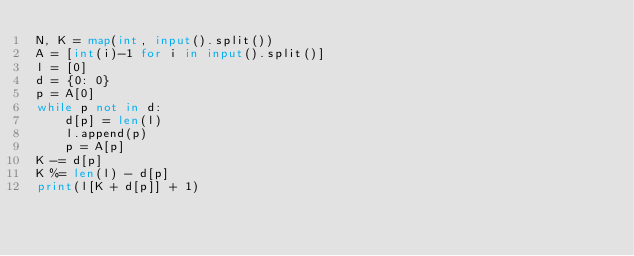Convert code to text. <code><loc_0><loc_0><loc_500><loc_500><_Python_>N, K = map(int, input().split())
A = [int(i)-1 for i in input().split()]
l = [0]
d = {0: 0}
p = A[0]
while p not in d:
    d[p] = len(l)
    l.append(p)
    p = A[p]
K -= d[p]
K %= len(l) - d[p]
print(l[K + d[p]] + 1)</code> 